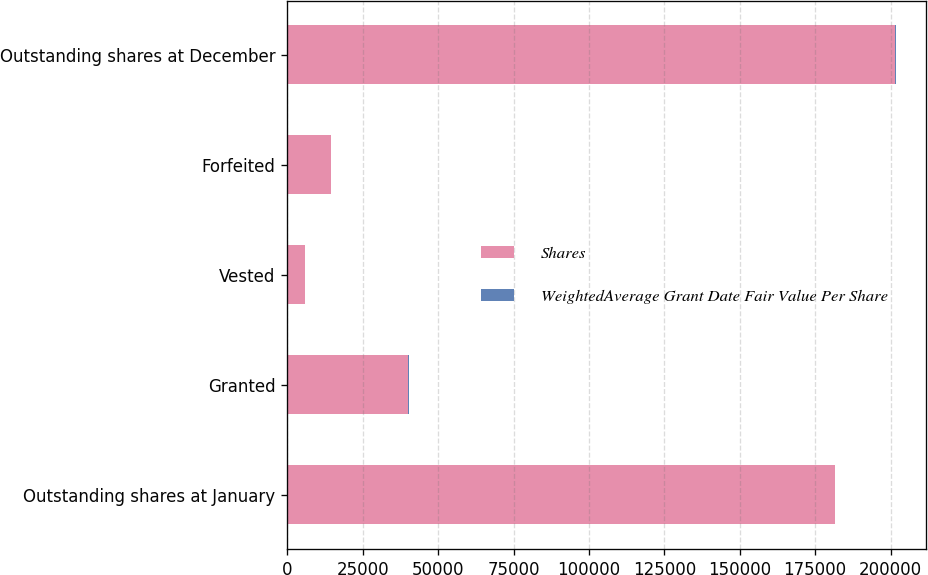Convert chart to OTSL. <chart><loc_0><loc_0><loc_500><loc_500><stacked_bar_chart><ecel><fcel>Outstanding shares at January<fcel>Granted<fcel>Vested<fcel>Forfeited<fcel>Outstanding shares at December<nl><fcel>Shares<fcel>181650<fcel>40170<fcel>5800<fcel>14450<fcel>201570<nl><fcel>WeightedAverage Grant Date Fair Value Per Share<fcel>74.94<fcel>79.1<fcel>73.22<fcel>79.69<fcel>75.48<nl></chart> 